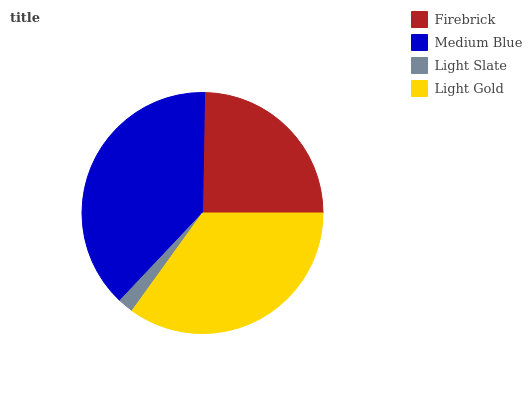Is Light Slate the minimum?
Answer yes or no. Yes. Is Medium Blue the maximum?
Answer yes or no. Yes. Is Medium Blue the minimum?
Answer yes or no. No. Is Light Slate the maximum?
Answer yes or no. No. Is Medium Blue greater than Light Slate?
Answer yes or no. Yes. Is Light Slate less than Medium Blue?
Answer yes or no. Yes. Is Light Slate greater than Medium Blue?
Answer yes or no. No. Is Medium Blue less than Light Slate?
Answer yes or no. No. Is Light Gold the high median?
Answer yes or no. Yes. Is Firebrick the low median?
Answer yes or no. Yes. Is Medium Blue the high median?
Answer yes or no. No. Is Light Slate the low median?
Answer yes or no. No. 